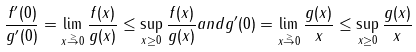<formula> <loc_0><loc_0><loc_500><loc_500>\frac { f ^ { \prime } ( 0 ) } { g ^ { \prime } ( 0 ) } = \lim _ { x \stackrel { \geq } { \rightarrow } 0 } \frac { f ( x ) } { g ( x ) } \leq \sup _ { x \geq 0 } \frac { f ( x ) } { g ( x ) } a n d g ^ { \prime } ( 0 ) = \lim _ { x \stackrel { \geq } { \rightarrow } 0 } \frac { g ( x ) } { x } \leq \sup _ { x \geq 0 } \frac { g ( x ) } { x }</formula> 